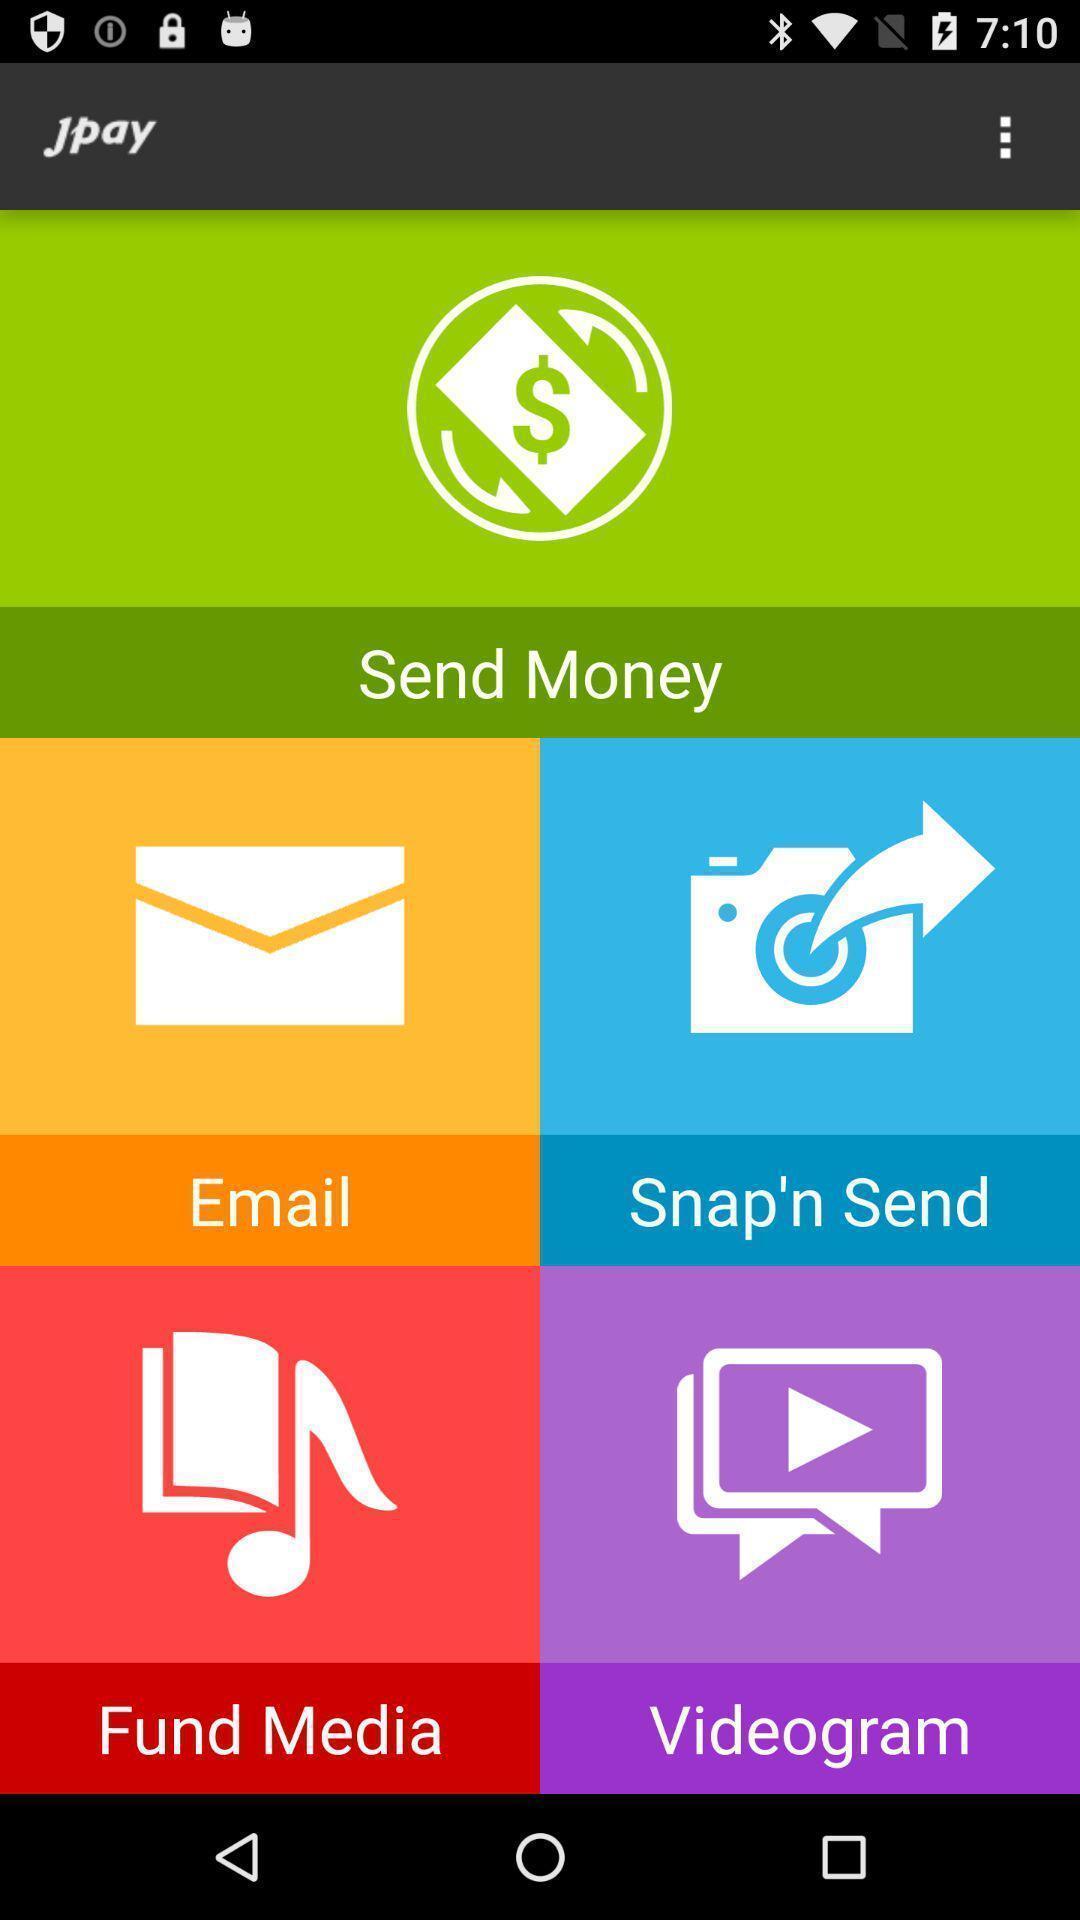What is the overall content of this screenshot? Screen showing the multiple options. 